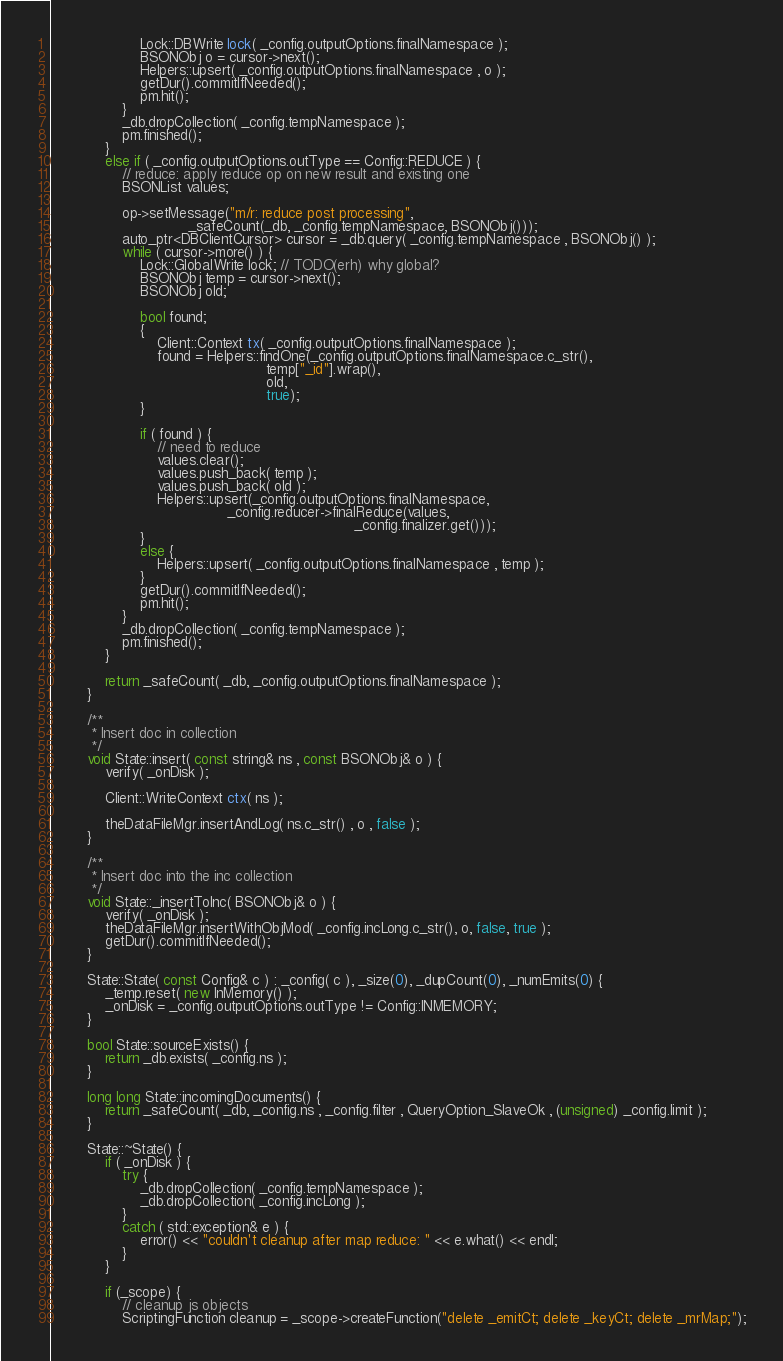<code> <loc_0><loc_0><loc_500><loc_500><_C++_>                    Lock::DBWrite lock( _config.outputOptions.finalNamespace );
                    BSONObj o = cursor->next();
                    Helpers::upsert( _config.outputOptions.finalNamespace , o );
                    getDur().commitIfNeeded();
                    pm.hit();
                }
                _db.dropCollection( _config.tempNamespace );
                pm.finished();
            }
            else if ( _config.outputOptions.outType == Config::REDUCE ) {
                // reduce: apply reduce op on new result and existing one
                BSONList values;

                op->setMessage("m/r: reduce post processing",
                               _safeCount(_db, _config.tempNamespace, BSONObj()));
                auto_ptr<DBClientCursor> cursor = _db.query( _config.tempNamespace , BSONObj() );
                while ( cursor->more() ) {
                    Lock::GlobalWrite lock; // TODO(erh) why global?
                    BSONObj temp = cursor->next();
                    BSONObj old;

                    bool found;
                    {
                        Client::Context tx( _config.outputOptions.finalNamespace );
                        found = Helpers::findOne(_config.outputOptions.finalNamespace.c_str(),
                                                 temp["_id"].wrap(),
                                                 old,
                                                 true);
                    }

                    if ( found ) {
                        // need to reduce
                        values.clear();
                        values.push_back( temp );
                        values.push_back( old );
                        Helpers::upsert(_config.outputOptions.finalNamespace,
                                        _config.reducer->finalReduce(values,
                                                                     _config.finalizer.get()));
                    }
                    else {
                        Helpers::upsert( _config.outputOptions.finalNamespace , temp );
                    }
                    getDur().commitIfNeeded();
                    pm.hit();
                }
                _db.dropCollection( _config.tempNamespace );
                pm.finished();
            }

            return _safeCount( _db, _config.outputOptions.finalNamespace );
        }

        /**
         * Insert doc in collection
         */
        void State::insert( const string& ns , const BSONObj& o ) {
            verify( _onDisk );

            Client::WriteContext ctx( ns );

            theDataFileMgr.insertAndLog( ns.c_str() , o , false );
        }

        /**
         * Insert doc into the inc collection
         */
        void State::_insertToInc( BSONObj& o ) {
            verify( _onDisk );
            theDataFileMgr.insertWithObjMod( _config.incLong.c_str(), o, false, true );
            getDur().commitIfNeeded();
        }

        State::State( const Config& c ) : _config( c ), _size(0), _dupCount(0), _numEmits(0) {
            _temp.reset( new InMemory() );
            _onDisk = _config.outputOptions.outType != Config::INMEMORY;
        }

        bool State::sourceExists() {
            return _db.exists( _config.ns );
        }

        long long State::incomingDocuments() {
            return _safeCount( _db, _config.ns , _config.filter , QueryOption_SlaveOk , (unsigned) _config.limit );
        }

        State::~State() {
            if ( _onDisk ) {
                try {
                    _db.dropCollection( _config.tempNamespace );
                    _db.dropCollection( _config.incLong );
                }
                catch ( std::exception& e ) {
                    error() << "couldn't cleanup after map reduce: " << e.what() << endl;
                }
            }

            if (_scope) {
                // cleanup js objects
                ScriptingFunction cleanup = _scope->createFunction("delete _emitCt; delete _keyCt; delete _mrMap;");</code> 